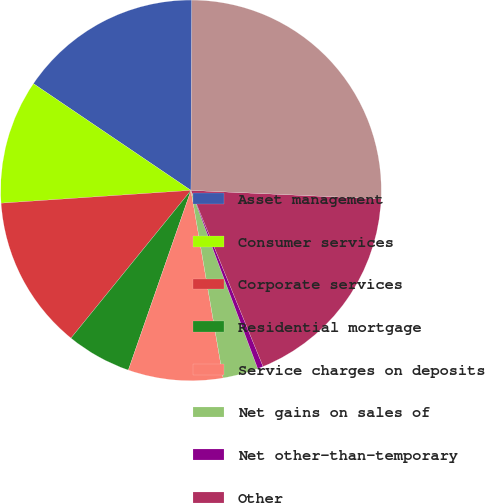Convert chart to OTSL. <chart><loc_0><loc_0><loc_500><loc_500><pie_chart><fcel>Asset management<fcel>Consumer services<fcel>Corporate services<fcel>Residential mortgage<fcel>Service charges on deposits<fcel>Net gains on sales of<fcel>Net other-than-temporary<fcel>Other<fcel>Total noninterest income<nl><fcel>15.59%<fcel>10.55%<fcel>13.07%<fcel>5.52%<fcel>8.04%<fcel>3.0%<fcel>0.48%<fcel>18.1%<fcel>25.65%<nl></chart> 